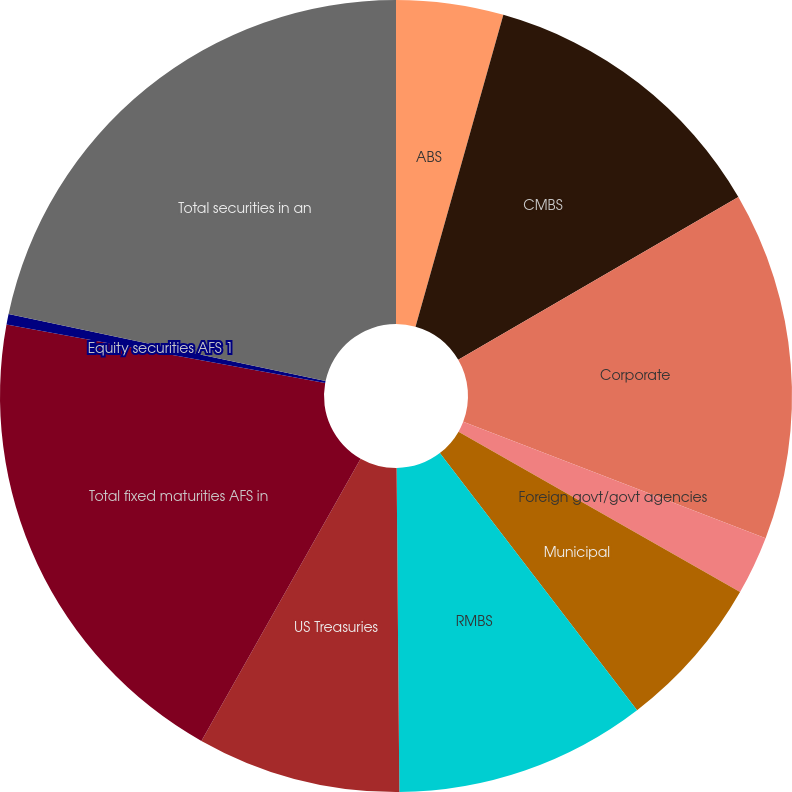Convert chart. <chart><loc_0><loc_0><loc_500><loc_500><pie_chart><fcel>ABS<fcel>CMBS<fcel>Corporate<fcel>Foreign govt/govt agencies<fcel>Municipal<fcel>RMBS<fcel>US Treasuries<fcel>Total fixed maturities AFS in<fcel>Equity securities AFS 1<fcel>Total securities in an<nl><fcel>4.37%<fcel>12.25%<fcel>14.22%<fcel>2.4%<fcel>6.34%<fcel>10.28%<fcel>8.31%<fcel>19.71%<fcel>0.43%<fcel>21.68%<nl></chart> 